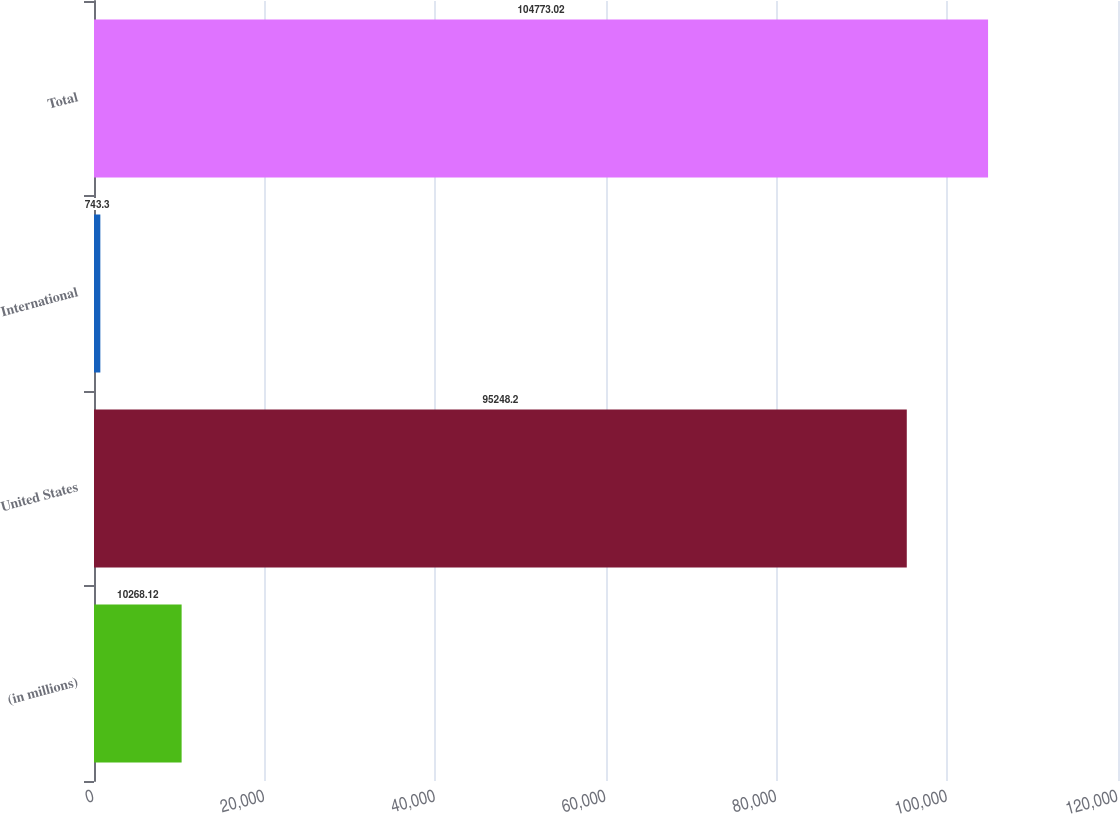Convert chart to OTSL. <chart><loc_0><loc_0><loc_500><loc_500><bar_chart><fcel>(in millions)<fcel>United States<fcel>International<fcel>Total<nl><fcel>10268.1<fcel>95248.2<fcel>743.3<fcel>104773<nl></chart> 